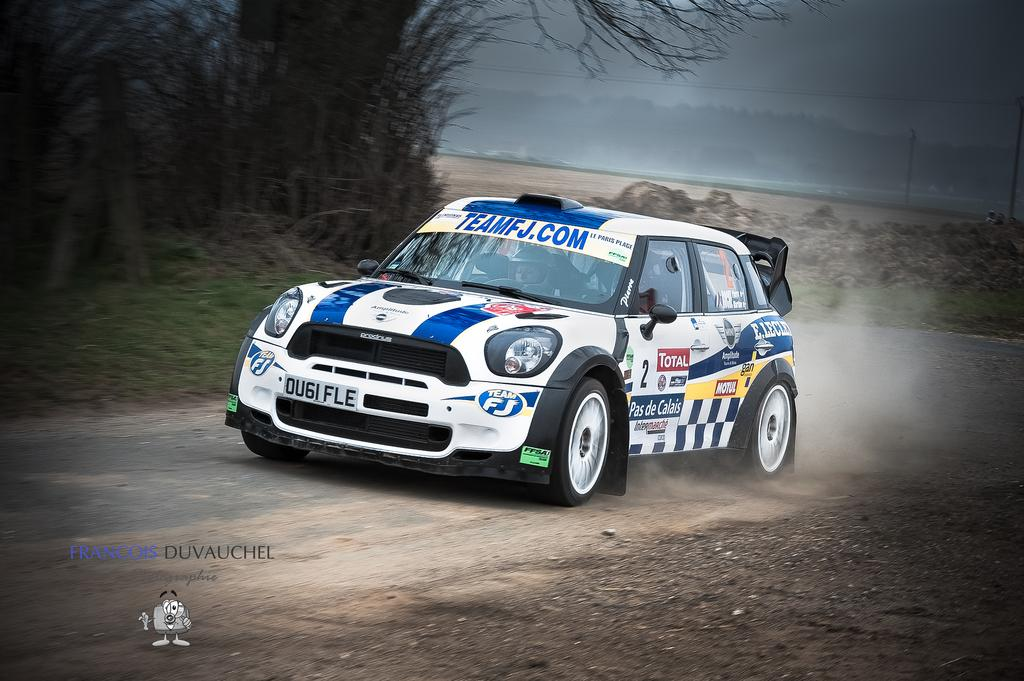What type of vehicle is in the picture? There is a sports car in the picture. What safety precaution is the person riding the sports car taking? The person riding the sports car is wearing a helmet. What type of natural environment can be seen in the picture? There are trees visible in the picture. What is the condition of the sky in the picture? The sky is clear in the picture. What type of cake is being served at the person's birthday party in the image? There is no birthday party or cake present in the image; it features a sports car and a person wearing a helmet. Can you tell me how many ants are crawling on the sports car in the image? There are no ants visible on the sports car in the image. 